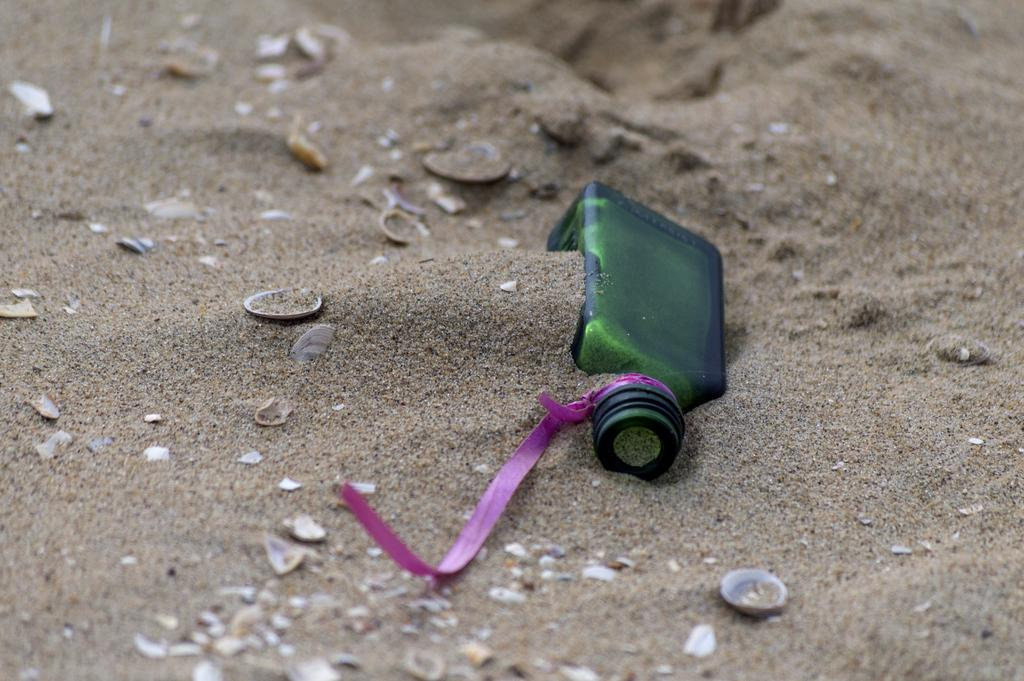What object can be seen in the image? There is a bottle in the image. Where is the bottle located? The bottle is in the sand. What type of plant is growing near the bottle in the image? There is no plant visible in the image; it only shows a bottle in the sand. 